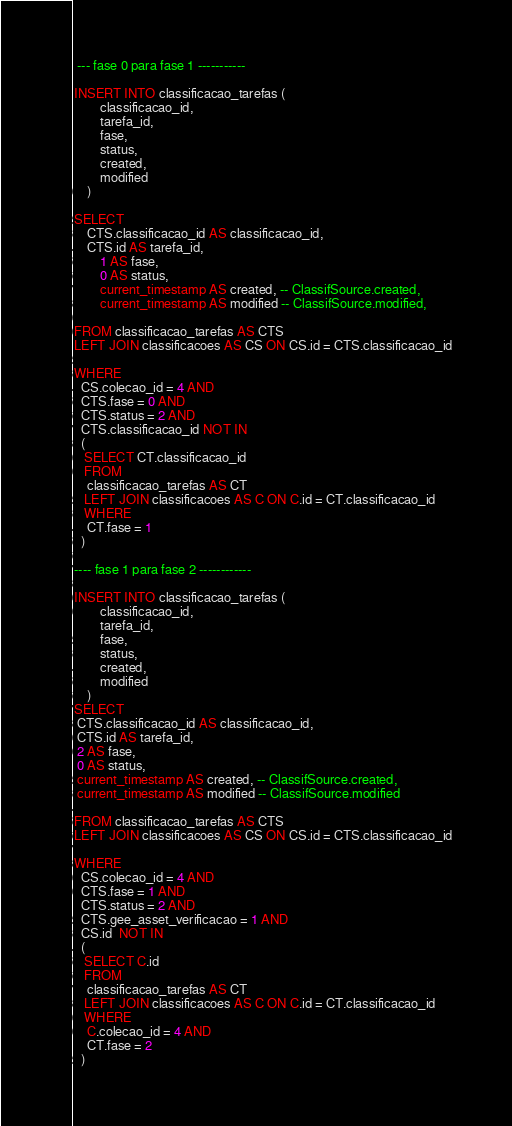Convert code to text. <code><loc_0><loc_0><loc_500><loc_500><_SQL_>
 --- fase 0 para fase 1 -----------

INSERT INTO classificacao_tarefas (		
		classificacao_id,
		tarefa_id,
		fase,
		status,		
		created,
		modified
	) 

SELECT 
  	CTS.classificacao_id AS classificacao_id,
    CTS.id AS tarefa_id,
		1 AS fase,
		0 AS status,
		current_timestamp AS created, -- ClassifSource.created,
		current_timestamp AS modified -- ClassifSource.modified,		

FROM classificacao_tarefas AS CTS
LEFT JOIN classificacoes AS CS ON CS.id = CTS.classificacao_id

WHERE
  CS.colecao_id = 4 AND  
  CTS.fase = 0 AND  
  CTS.status = 2 AND    
  CTS.classificacao_id NOT IN 
  (
   SELECT CT.classificacao_id
   FROM
    classificacao_tarefas AS CT
   LEFT JOIN classificacoes AS C ON C.id = CT.classificacao_id
   WHERE    
    CT.fase = 1
  ) 

---- fase 1 para fase 2 ------------

INSERT INTO classificacao_tarefas (		
		classificacao_id,
		tarefa_id,
		fase,
		status,		
		created,
		modified
	) 
SELECT 
 CTS.classificacao_id AS classificacao_id,
 CTS.id AS tarefa_id,
 2 AS fase,
 0 AS status,
 current_timestamp AS created, -- ClassifSource.created,
 current_timestamp AS modified -- ClassifSource.modified

FROM classificacao_tarefas AS CTS
LEFT JOIN classificacoes AS CS ON CS.id = CTS.classificacao_id

WHERE
  CS.colecao_id = 4 AND
  CTS.fase = 1 AND  
  CTS.status = 2 AND
  CTS.gee_asset_verificacao = 1 AND
  CS.id  NOT IN 
  (
   SELECT C.id
   FROM
    classificacao_tarefas AS CT
   LEFT JOIN classificacoes AS C ON C.id = CT.classificacao_id
   WHERE    
    C.colecao_id = 4 AND
    CT.fase = 2
  ) 
</code> 